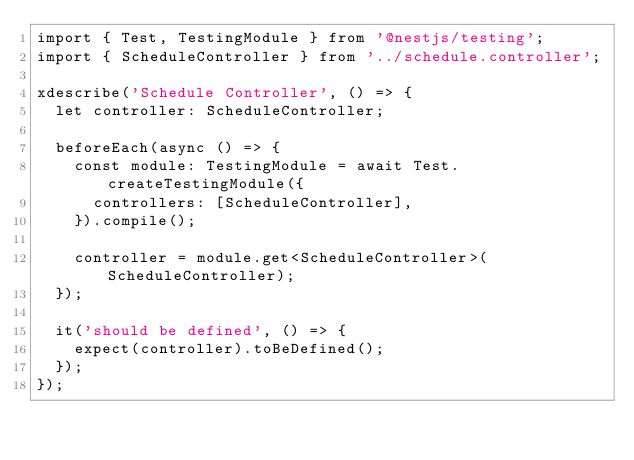Convert code to text. <code><loc_0><loc_0><loc_500><loc_500><_TypeScript_>import { Test, TestingModule } from '@nestjs/testing';
import { ScheduleController } from '../schedule.controller';

xdescribe('Schedule Controller', () => {
  let controller: ScheduleController;

  beforeEach(async () => {
    const module: TestingModule = await Test.createTestingModule({
      controllers: [ScheduleController],
    }).compile();

    controller = module.get<ScheduleController>(ScheduleController);
  });

  it('should be defined', () => {
    expect(controller).toBeDefined();
  });
});
</code> 